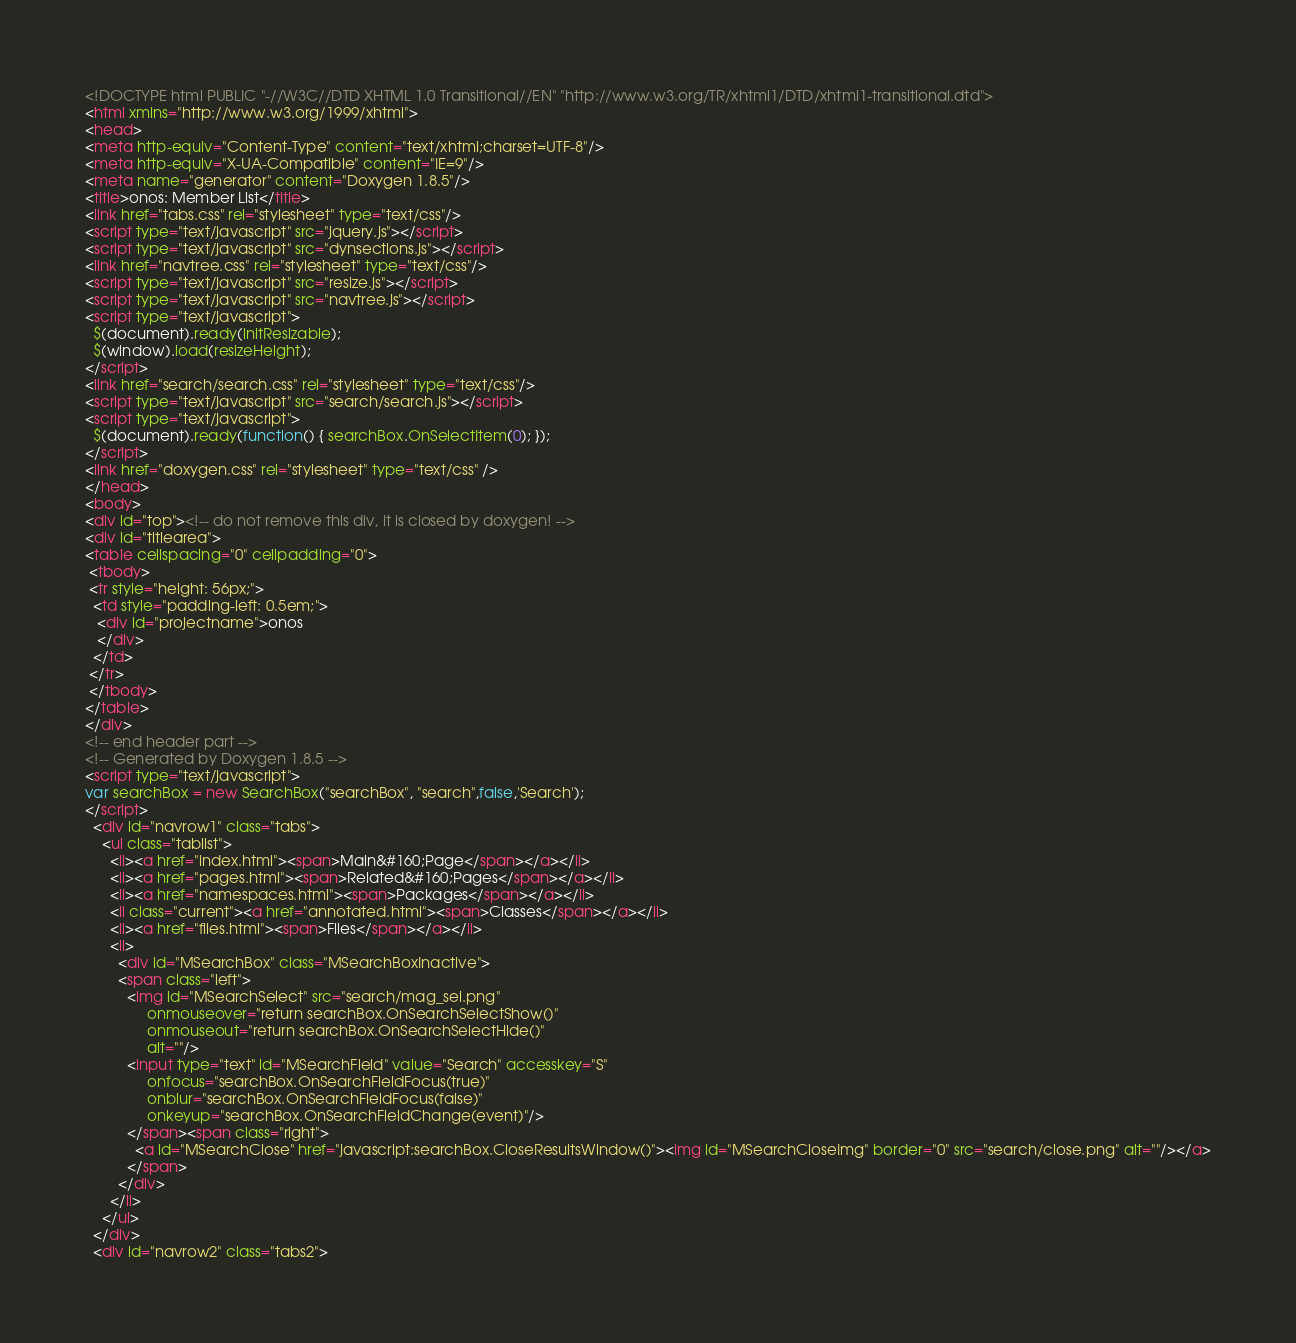<code> <loc_0><loc_0><loc_500><loc_500><_HTML_><!DOCTYPE html PUBLIC "-//W3C//DTD XHTML 1.0 Transitional//EN" "http://www.w3.org/TR/xhtml1/DTD/xhtml1-transitional.dtd">
<html xmlns="http://www.w3.org/1999/xhtml">
<head>
<meta http-equiv="Content-Type" content="text/xhtml;charset=UTF-8"/>
<meta http-equiv="X-UA-Compatible" content="IE=9"/>
<meta name="generator" content="Doxygen 1.8.5"/>
<title>onos: Member List</title>
<link href="tabs.css" rel="stylesheet" type="text/css"/>
<script type="text/javascript" src="jquery.js"></script>
<script type="text/javascript" src="dynsections.js"></script>
<link href="navtree.css" rel="stylesheet" type="text/css"/>
<script type="text/javascript" src="resize.js"></script>
<script type="text/javascript" src="navtree.js"></script>
<script type="text/javascript">
  $(document).ready(initResizable);
  $(window).load(resizeHeight);
</script>
<link href="search/search.css" rel="stylesheet" type="text/css"/>
<script type="text/javascript" src="search/search.js"></script>
<script type="text/javascript">
  $(document).ready(function() { searchBox.OnSelectItem(0); });
</script>
<link href="doxygen.css" rel="stylesheet" type="text/css" />
</head>
<body>
<div id="top"><!-- do not remove this div, it is closed by doxygen! -->
<div id="titlearea">
<table cellspacing="0" cellpadding="0">
 <tbody>
 <tr style="height: 56px;">
  <td style="padding-left: 0.5em;">
   <div id="projectname">onos
   </div>
  </td>
 </tr>
 </tbody>
</table>
</div>
<!-- end header part -->
<!-- Generated by Doxygen 1.8.5 -->
<script type="text/javascript">
var searchBox = new SearchBox("searchBox", "search",false,'Search');
</script>
  <div id="navrow1" class="tabs">
    <ul class="tablist">
      <li><a href="index.html"><span>Main&#160;Page</span></a></li>
      <li><a href="pages.html"><span>Related&#160;Pages</span></a></li>
      <li><a href="namespaces.html"><span>Packages</span></a></li>
      <li class="current"><a href="annotated.html"><span>Classes</span></a></li>
      <li><a href="files.html"><span>Files</span></a></li>
      <li>
        <div id="MSearchBox" class="MSearchBoxInactive">
        <span class="left">
          <img id="MSearchSelect" src="search/mag_sel.png"
               onmouseover="return searchBox.OnSearchSelectShow()"
               onmouseout="return searchBox.OnSearchSelectHide()"
               alt=""/>
          <input type="text" id="MSearchField" value="Search" accesskey="S"
               onfocus="searchBox.OnSearchFieldFocus(true)" 
               onblur="searchBox.OnSearchFieldFocus(false)" 
               onkeyup="searchBox.OnSearchFieldChange(event)"/>
          </span><span class="right">
            <a id="MSearchClose" href="javascript:searchBox.CloseResultsWindow()"><img id="MSearchCloseImg" border="0" src="search/close.png" alt=""/></a>
          </span>
        </div>
      </li>
    </ul>
  </div>
  <div id="navrow2" class="tabs2"></code> 